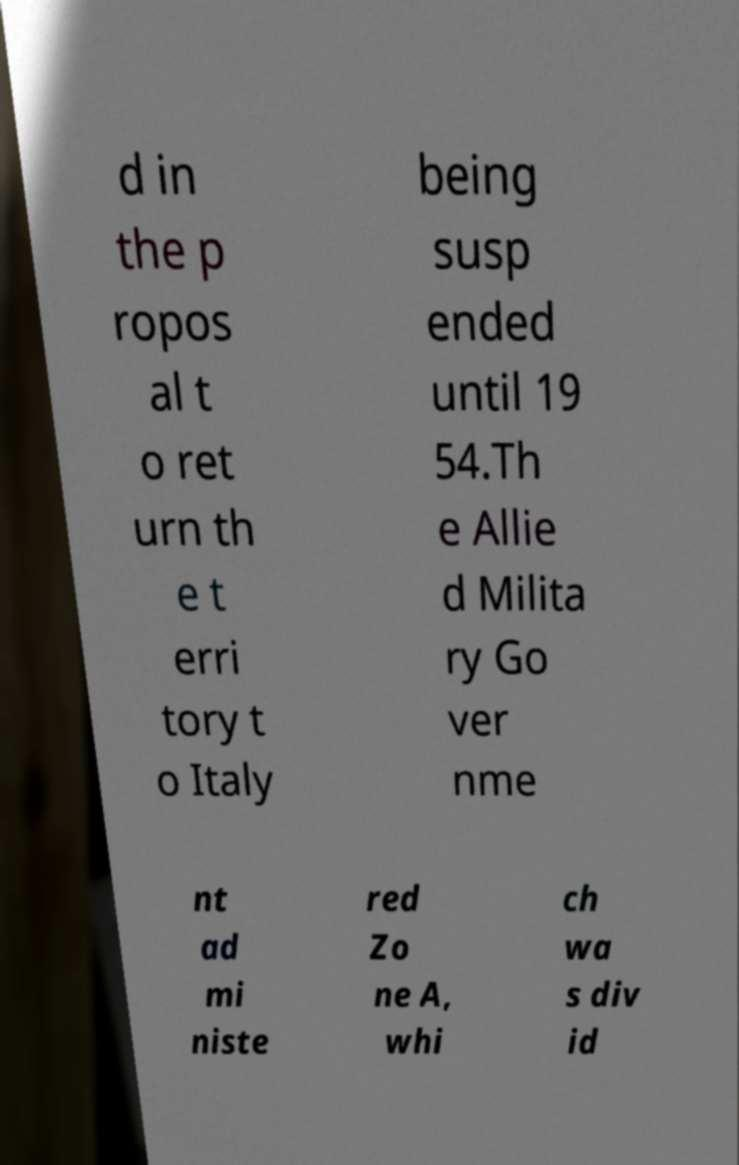Can you read and provide the text displayed in the image?This photo seems to have some interesting text. Can you extract and type it out for me? d in the p ropos al t o ret urn th e t erri tory t o Italy being susp ended until 19 54.Th e Allie d Milita ry Go ver nme nt ad mi niste red Zo ne A, whi ch wa s div id 